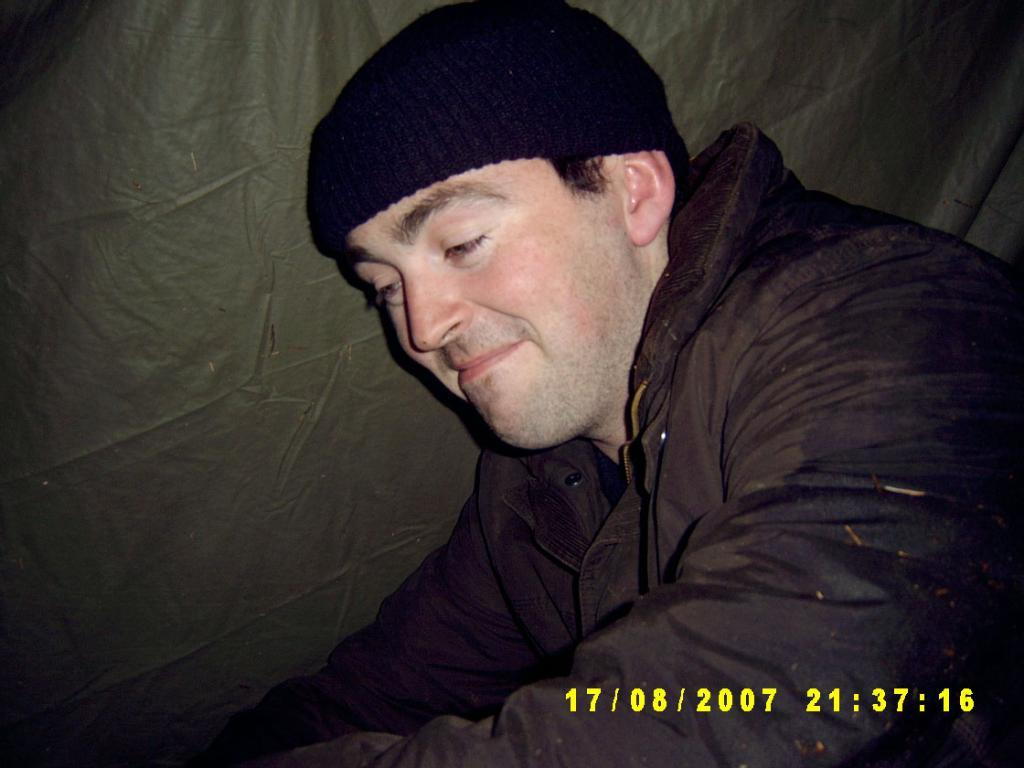Who or what is present in the image? There is a person in the image. What type of clothing is the person wearing? The person is wearing a jacket and a skull cap. What object is located beside the person? There is a sheet beside the person. What type of wine is the person holding in the image? There is no wine present in the image; the person is not holding any wine. 